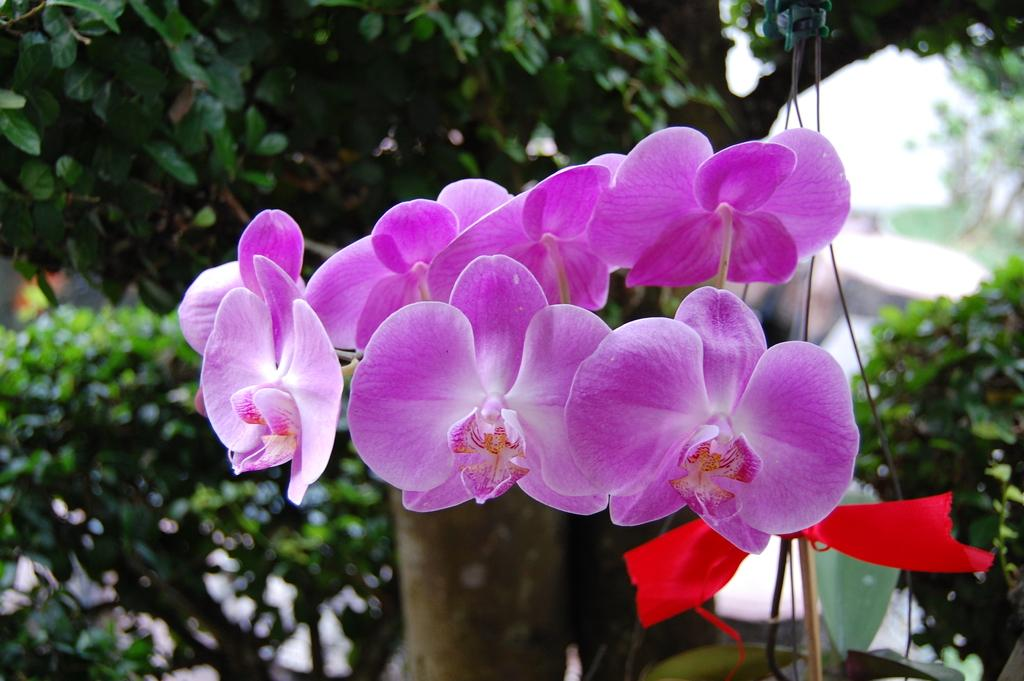What type of plants can be seen in the image? There are flowers in the image. What additional object is present in the image? There is a ribbon in the image. Where is the ribbon located in the image? The ribbon is on the right side of the image. What part of a tree can be seen in the image? There are leaves of a tree visible in the image. What type of soda is being advertised by the kite in the image? There is no kite or soda present in the image. How does the society depicted in the image react to the flowers? There is no society depicted in the image, only flowers, a ribbon, and leaves of a tree. 